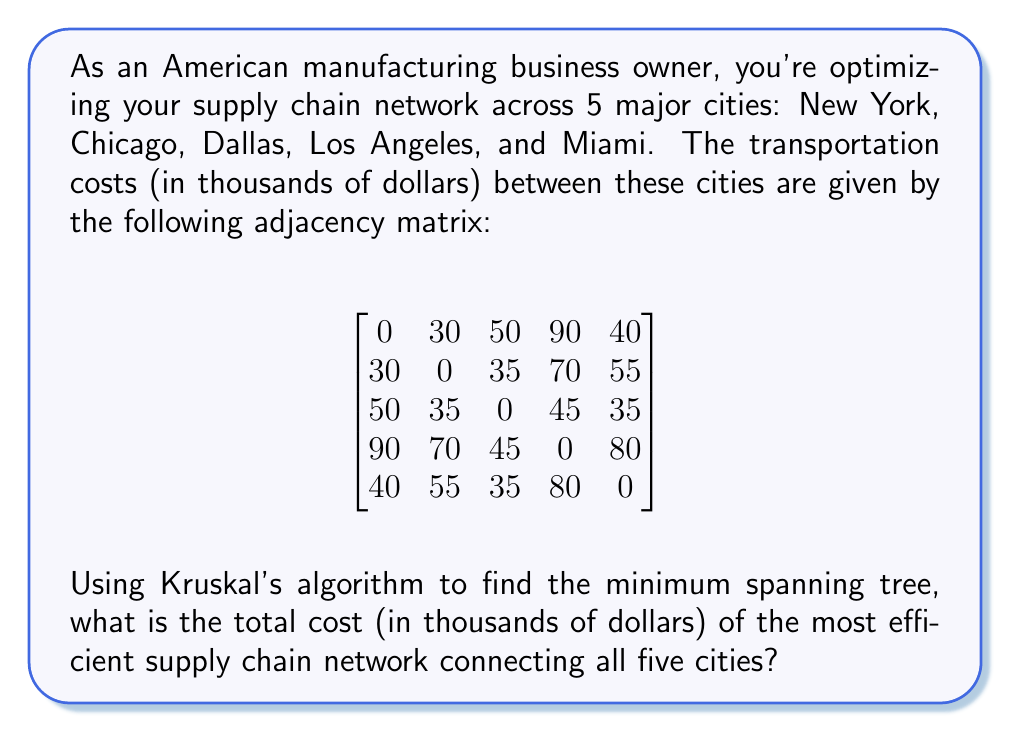Can you solve this math problem? To solve this problem, we'll use Kruskal's algorithm to find the minimum spanning tree (MST) of the graph representing our supply chain network. This will give us the most efficient network connecting all cities with the lowest total cost.

Step 1: Sort all edges by weight (cost) in ascending order:
1. New York - Chicago: 30
2. Dallas - Miami: 35
3. Chicago - Dallas: 35
4. New York - Miami: 40
5. Dallas - Los Angeles: 45
6. Chicago - Miami: 55
7. Chicago - Los Angeles: 70
8. Los Angeles - Miami: 80
9. New York - Los Angeles: 90

Step 2: Apply Kruskal's algorithm:
1. Add New York - Chicago (30)
2. Add Dallas - Miami (35)
3. Add Chicago - Dallas (35)
4. Skip New York - Miami (would create a cycle)
5. Add Dallas - Los Angeles (45)

At this point, we have connected all 5 cities without creating any cycles, so we stop.

Step 3: Calculate the total cost of the MST:
Total cost = 30 + 35 + 35 + 45 = 145 thousand dollars

Therefore, the most efficient supply chain network connecting all five cities has a total cost of $145,000.
Answer: $145,000 